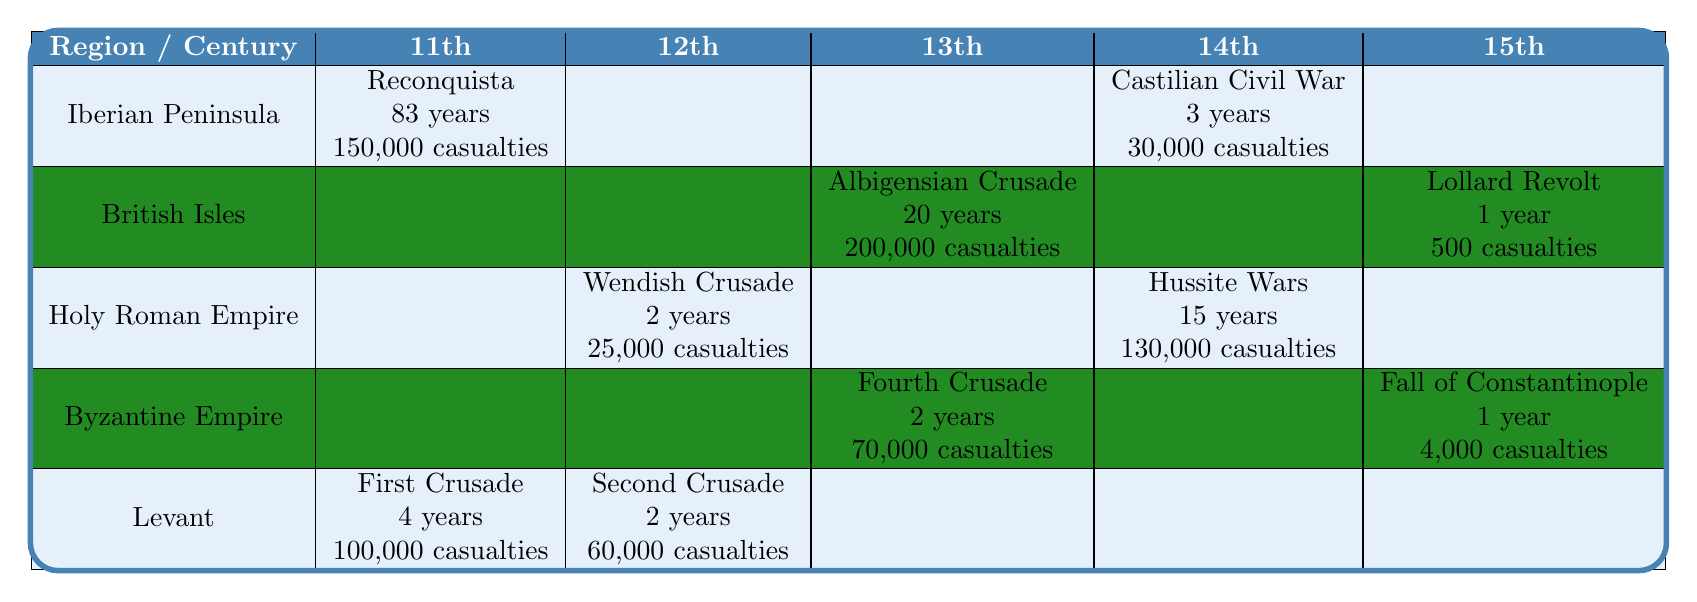What religious conflict occurred in the Iberian Peninsula during the 11th century? The table shows that the Reconquista campaigns took place in the Iberian Peninsula during the 11th century.
Answer: Reconquista campaigns How many casualties were reported during the Second Crusade in the Levant? The table indicates that the Second Crusade in the Levant resulted in 60,000 casualties.
Answer: 60,000 Which conflict had the longest duration in the 13th century? By examining the table, the Albigensian Crusade in the British Isles lasted for 20 years, which is the longest duration listed in the 13th century.
Answer: Albigensian Crusade How many total casualties were reported from the conflicts in the Byzantine Empire? The table presents 70,000 casualties from the Fourth Crusade and 4,000 casualties from the Fall of Constantinople in the Byzantine Empire. Adding these gives 70,000 + 4,000 = 74,000 casualties.
Answer: 74,000 Did the Iberian Peninsula experience any conflicts in the 12th and 15th centuries? The table shows no listed conflicts for the Iberian Peninsula during the 12th and 15th centuries. It only shows conflicts in the 11th and 14th centuries. Therefore, the answer is no.
Answer: No What was the average duration of conflicts in the Holy Roman Empire? The table provides durations of 2 years for the Wendish Crusade and 15 years for the Hussite Wars. To find the average, add the durations (2 + 15 = 17) and divide by the number of conflicts (17 / 2 = 8.5).
Answer: 8.5 years Which region had the highest number of casualties during the 13th century? The table lists 200,000 casualties from the Albigensian Crusade in the British Isles and 70,000 from the Fourth Crusade in the Byzantine Empire. The highest number is from the British Isles.
Answer: British Isles What were the primary religious events in the Levant during the 12th century? Looking at the table, the Second Crusade is the only event listed in the Levant for the 12th century.
Answer: Second Crusade How many conflicts are recorded for the British Isles over the centuries? The table shows two conflicts for the British Isles: the Albigensian Crusade in the 13th century and the Lollard Revolt in the 15th century.
Answer: 2 conflicts Did the Iberian Peninsula have a conflict recorded in the 14th century? According to the table, there is a conflict noted for the Iberian Peninsula in the 14th century, specifically the Castilian Civil War. Therefore, the answer is yes.
Answer: Yes 